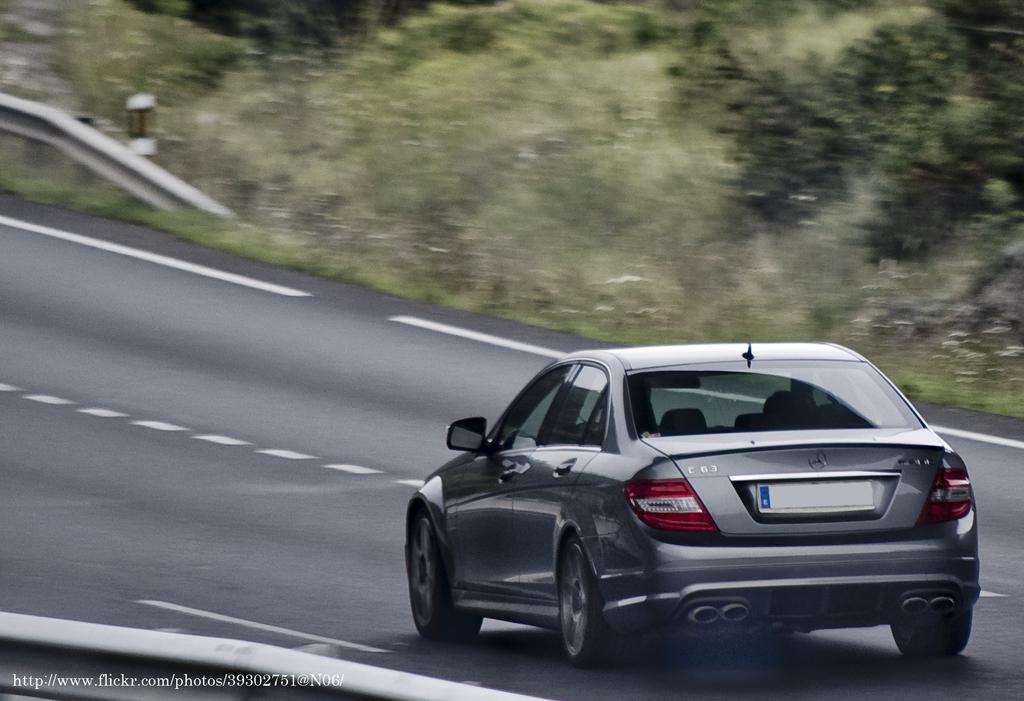Could you give a brief overview of what you see in this image? There is a gray color vehicle on the road on which, there are white color marks. Near the vehicle, there is a fencing. In front of this, there is watermark. In the background, there is grass, plants and trees on the ground and there is fencing. 